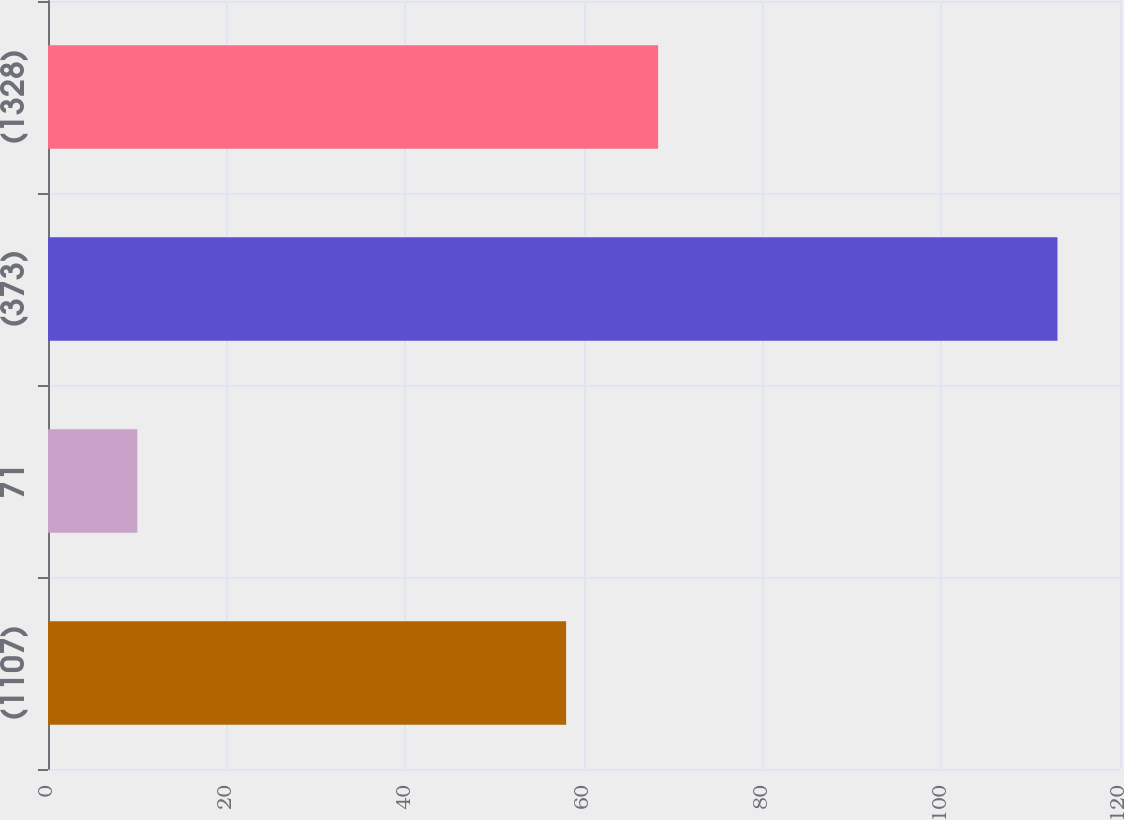Convert chart to OTSL. <chart><loc_0><loc_0><loc_500><loc_500><bar_chart><fcel>(1107)<fcel>71<fcel>(373)<fcel>(1328)<nl><fcel>58<fcel>10<fcel>113<fcel>68.3<nl></chart> 